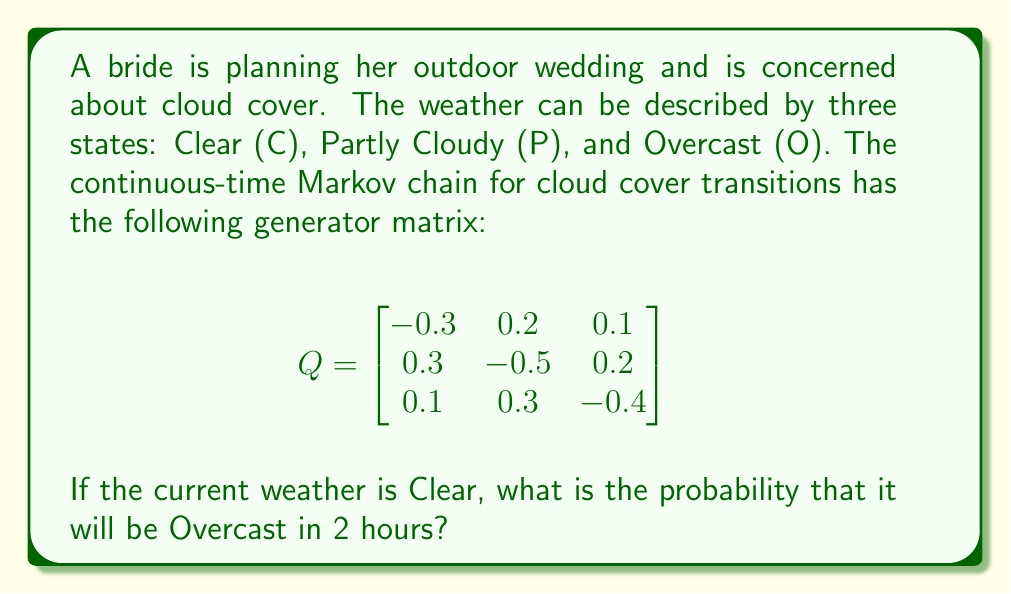Provide a solution to this math problem. To solve this problem, we need to follow these steps:

1) For a continuous-time Markov chain, the transition probability matrix $P(t)$ after time $t$ is given by:

   $$P(t) = e^{Qt}$$

   where $Q$ is the generator matrix and $e^{Qt}$ is the matrix exponential.

2) We need to calculate $P(2)$, as we're interested in the state after 2 hours.

3) To compute $e^{Qt}$, we can use the spectral decomposition method:
   
   a) Find the eigenvalues and eigenvectors of $Q$.
   b) Diagonalize $Q$ as $Q = ADA^{-1}$, where $D$ is a diagonal matrix of eigenvalues.
   c) Then, $e^{Qt} = Ae^{Dt}A^{-1}$.

4) However, for this problem, we can use a software tool or mathematical software to compute $e^{Q2}$ directly.

5) Using such a tool, we get:

   $$P(2) = e^{Q2} \approx \begin{bmatrix}
   0.5249 & 0.3137 & 0.1614 \\
   0.4706 & 0.3451 & 0.1843 \\
   0.3922 & 0.3725 & 0.2353
   \end{bmatrix}$$

6) The probability of transitioning from Clear (state 1) to Overcast (state 3) in 2 hours is given by the element in the first row, third column of this matrix.

Therefore, the probability is approximately 0.1614 or 16.14%.
Answer: 0.1614 